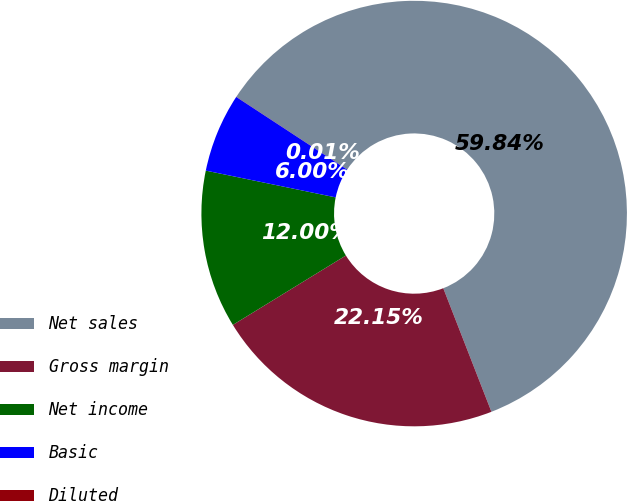Convert chart. <chart><loc_0><loc_0><loc_500><loc_500><pie_chart><fcel>Net sales<fcel>Gross margin<fcel>Net income<fcel>Basic<fcel>Diluted<nl><fcel>59.84%<fcel>22.15%<fcel>12.0%<fcel>6.0%<fcel>0.01%<nl></chart> 